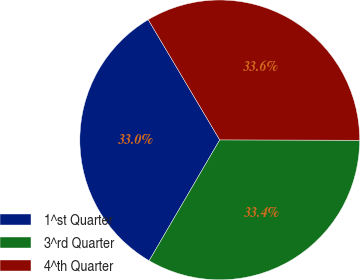Convert chart. <chart><loc_0><loc_0><loc_500><loc_500><pie_chart><fcel>1^st Quarter<fcel>3^rd Quarter<fcel>4^th Quarter<nl><fcel>33.04%<fcel>33.38%<fcel>33.57%<nl></chart> 